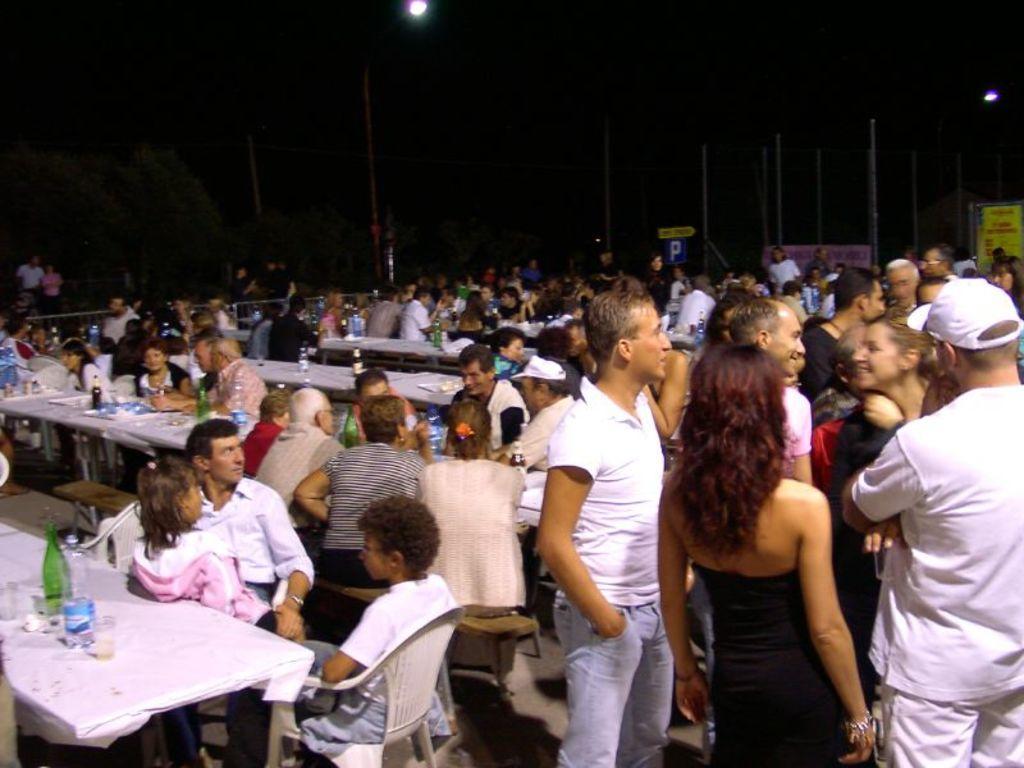Describe this image in one or two sentences. In this picture we can see crowd of people where some are sitting on chairs and some are standing and in front of them we have table and on table we can see glasses, bottles, tray and in the background we can see pole, banner, light , tree and it is dark. 